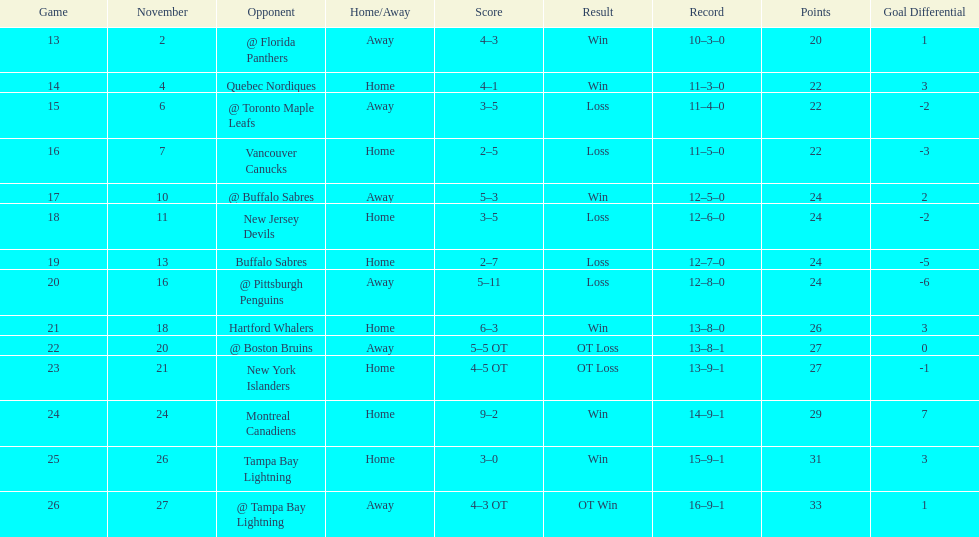Which was the only team in the atlantic division in the 1993-1994 season to acquire less points than the philadelphia flyers? Tampa Bay Lightning. 